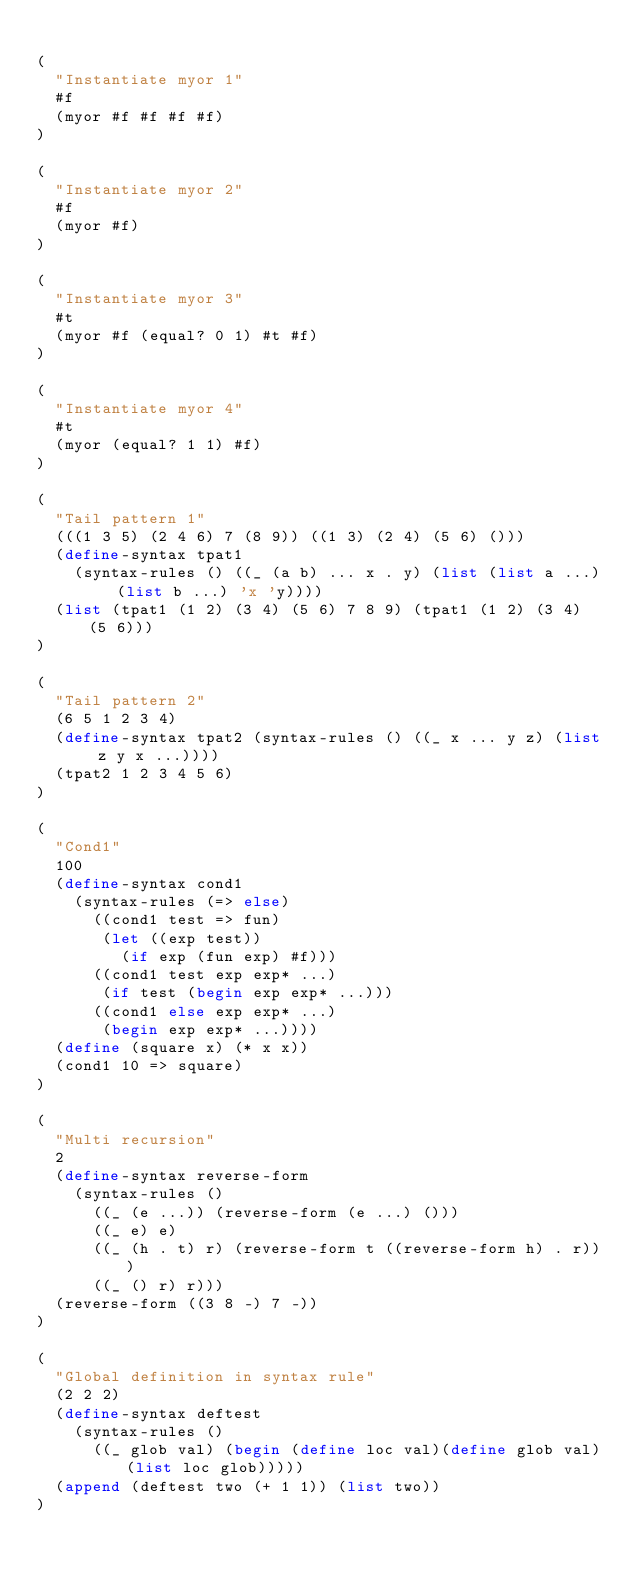Convert code to text. <code><loc_0><loc_0><loc_500><loc_500><_Scheme_>
(
  "Instantiate myor 1"
  #f
  (myor #f #f #f #f)
)

(
  "Instantiate myor 2"
  #f
  (myor #f)
)

(
  "Instantiate myor 3"
  #t
  (myor #f (equal? 0 1) #t #f)
)

(
  "Instantiate myor 4"
  #t
  (myor (equal? 1 1) #f)
)

(
  "Tail pattern 1"
  (((1 3 5) (2 4 6) 7 (8 9)) ((1 3) (2 4) (5 6) ()))
  (define-syntax tpat1
    (syntax-rules () ((_ (a b) ... x . y) (list (list a ...) (list b ...) 'x 'y))))
  (list (tpat1 (1 2) (3 4) (5 6) 7 8 9) (tpat1 (1 2) (3 4) (5 6)))
)

(
  "Tail pattern 2"
  (6 5 1 2 3 4)
  (define-syntax tpat2 (syntax-rules () ((_ x ... y z) (list z y x ...))))
  (tpat2 1 2 3 4 5 6)
)

(
  "Cond1"
  100
  (define-syntax cond1
    (syntax-rules (=> else)
      ((cond1 test => fun)
       (let ((exp test))
         (if exp (fun exp) #f)))
      ((cond1 test exp exp* ...)
       (if test (begin exp exp* ...)))
      ((cond1 else exp exp* ...)
       (begin exp exp* ...))))
  (define (square x) (* x x))
  (cond1 10 => square)
)

(
  "Multi recursion"
  2
  (define-syntax reverse-form
    (syntax-rules ()
      ((_ (e ...)) (reverse-form (e ...) ()))
      ((_ e) e)
      ((_ (h . t) r) (reverse-form t ((reverse-form h) . r)))
      ((_ () r) r)))
  (reverse-form ((3 8 -) 7 -))
)

(
  "Global definition in syntax rule"
  (2 2 2)
  (define-syntax deftest
    (syntax-rules ()
      ((_ glob val) (begin (define loc val)(define glob val)(list loc glob)))))
  (append (deftest two (+ 1 1)) (list two))
)
</code> 